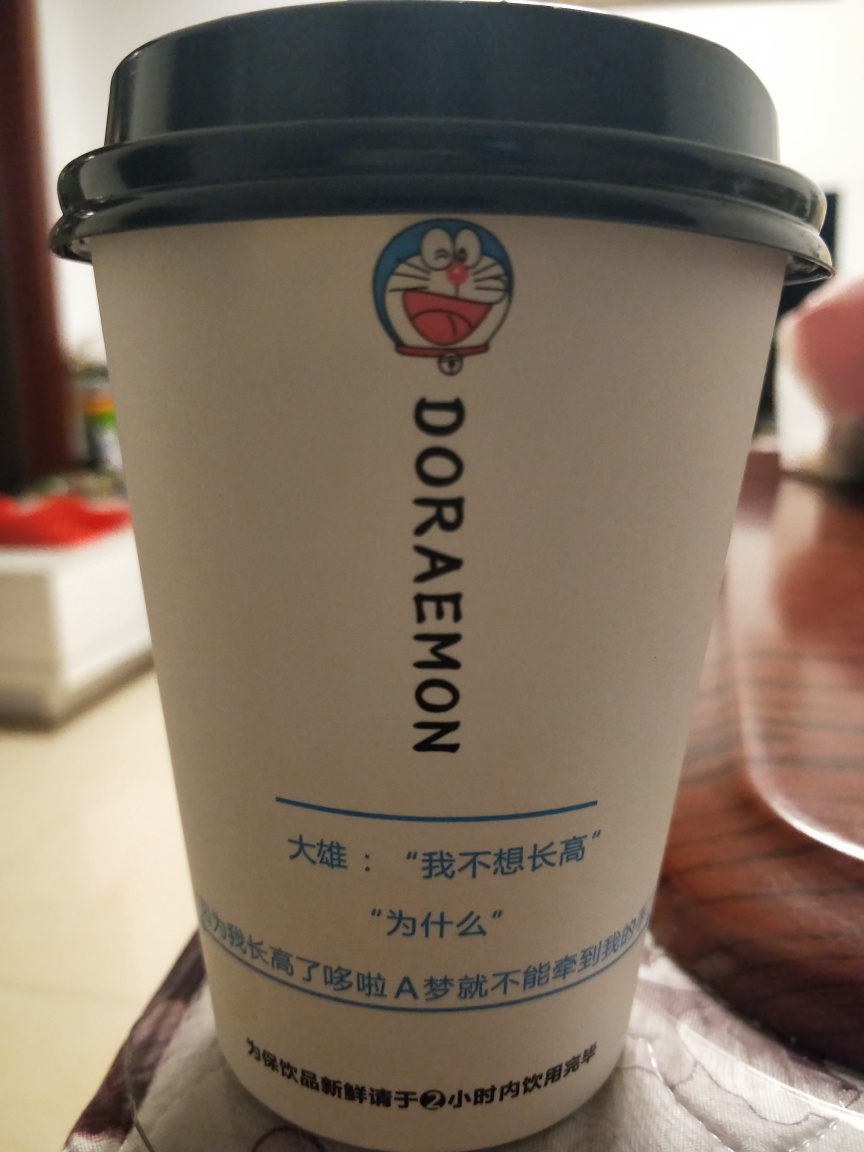Can you describe the design elements visible on the cup in this image? Certainly! The cup features the character Doraemon, prominently displayed with a joyful expression. Above the graphic, the text reads 'DORAEMON', identifying the character. Below the image, there are Chinese characters that likely provide some additional information related to the product or branding. 